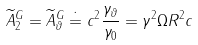Convert formula to latex. <formula><loc_0><loc_0><loc_500><loc_500>\widetilde { A } _ { 2 } ^ { G } = \widetilde { A } _ { \vartheta } ^ { G } \doteq c ^ { 2 } \frac { \gamma _ { \vartheta } } { \gamma _ { 0 } } = \gamma ^ { 2 } \Omega R ^ { 2 } c</formula> 